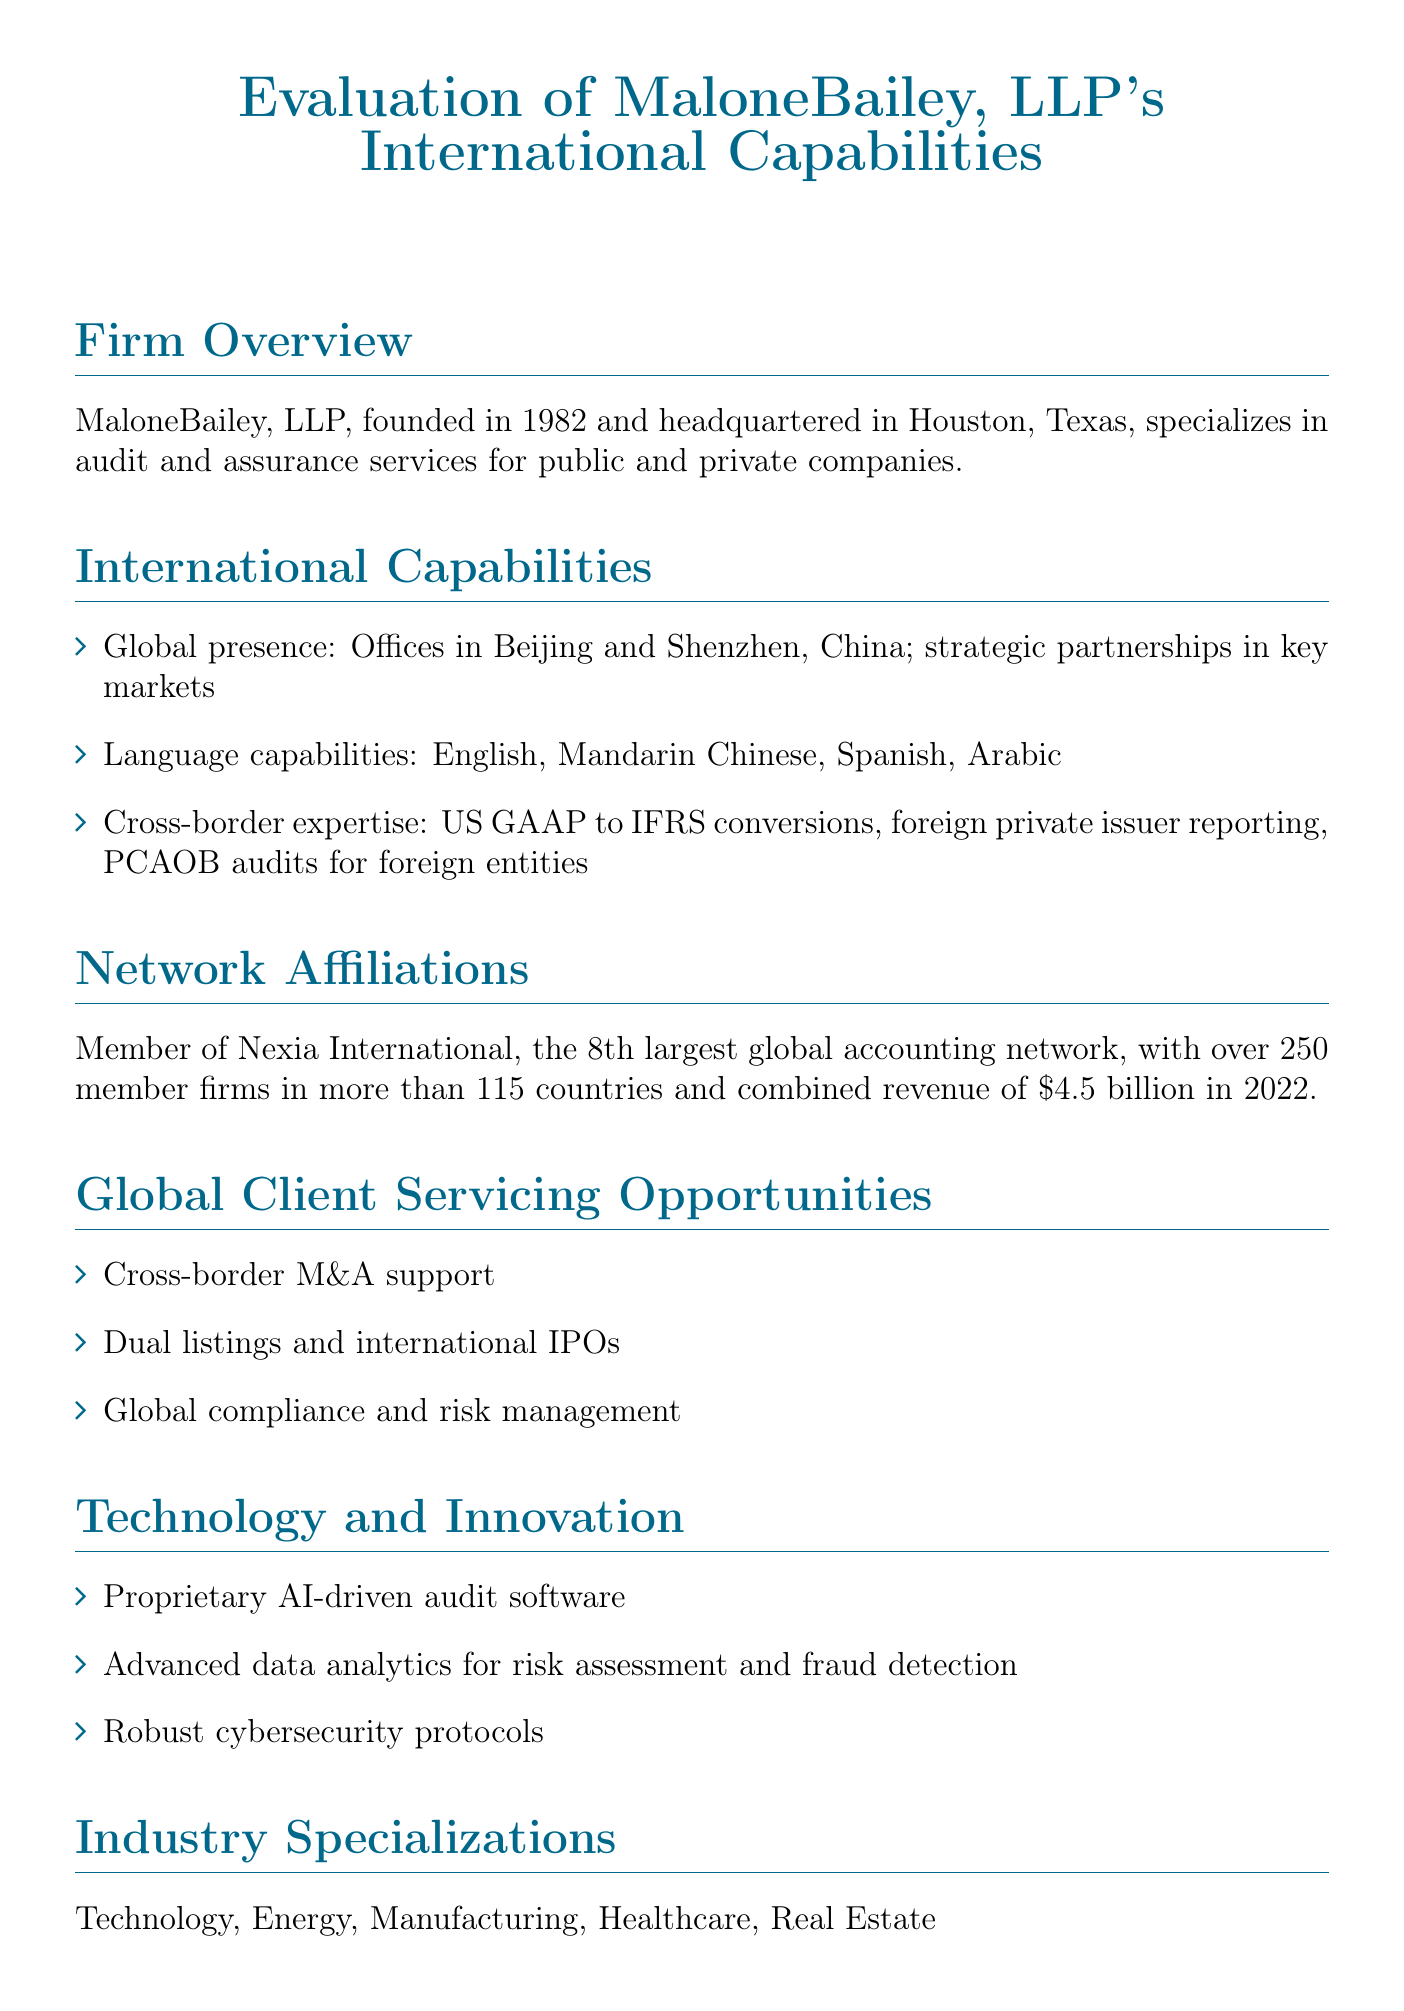What is the headquarters of MaloneBailey, LLP? The document states that MaloneBailey, LLP is headquartered in Houston, Texas.
Answer: Houston, Texas In what year was MaloneBailey, LLP founded? The founding year of MaloneBailey, LLP mentioned in the document is 1982.
Answer: 1982 How many member firms are in the Nexia International network? The document specifies that there are over 250 member firms in the Nexia International network.
Answer: Over 250 What is one area of global client servicing opportunities mentioned? The document lists "Cross-border M&A support" as one area of opportunity.
Answer: Cross-border M&A support What is the combined revenue of Nexia International in 2022? The document indicates that the combined revenue was $4.5 billion in 2022.
Answer: $4.5 billion Which languages can MaloneBailey, LLP provide services in? The language capabilities include English, Mandarin Chinese, Spanish, and Arabic as stated in the document.
Answer: English, Mandarin Chinese, Spanish, Arabic What type of collaboration model involves staff rotations? The document describes "Staff exchanges" as a collaboration model that involves staff rotations.
Answer: Staff exchanges What technology does MaloneBailey utilize for audits? The document notes the use of proprietary AI-driven audit software for audits.
Answer: AI-driven audit software What industries does MaloneBailey specialize in? The industries mentioned include Technology, Energy, Manufacturing, Healthcare, and Real Estate.
Answer: Technology, Energy, Manufacturing, Healthcare, Real Estate 